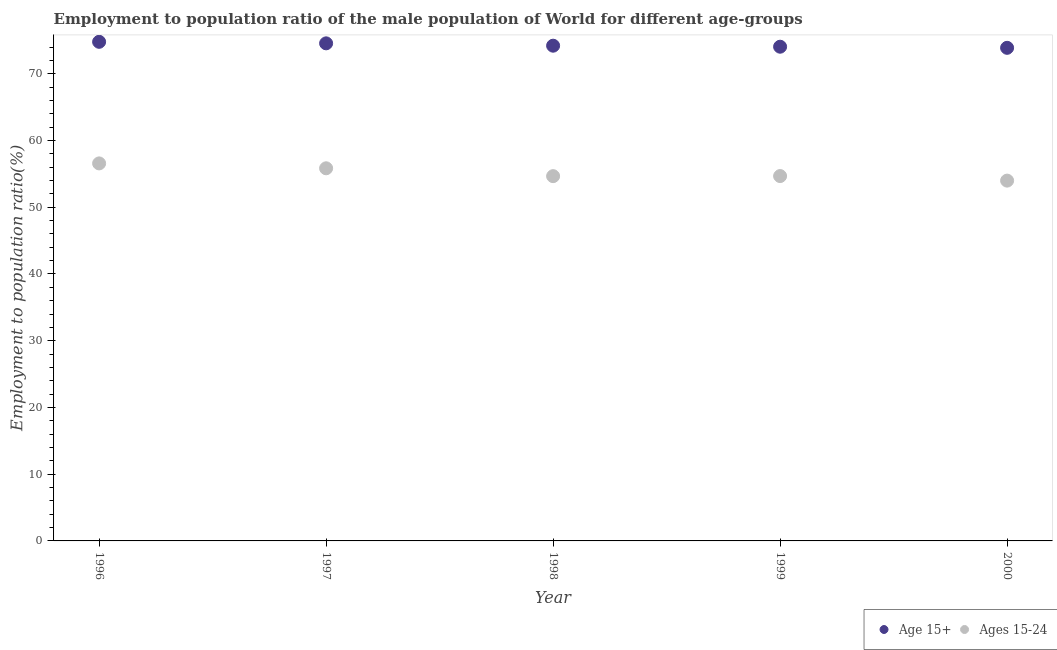How many different coloured dotlines are there?
Ensure brevity in your answer.  2. Is the number of dotlines equal to the number of legend labels?
Provide a succinct answer. Yes. What is the employment to population ratio(age 15+) in 1997?
Give a very brief answer. 74.57. Across all years, what is the maximum employment to population ratio(age 15-24)?
Provide a succinct answer. 56.57. Across all years, what is the minimum employment to population ratio(age 15-24)?
Keep it short and to the point. 53.99. In which year was the employment to population ratio(age 15+) maximum?
Your response must be concise. 1996. In which year was the employment to population ratio(age 15+) minimum?
Provide a succinct answer. 2000. What is the total employment to population ratio(age 15-24) in the graph?
Provide a succinct answer. 275.74. What is the difference between the employment to population ratio(age 15+) in 1997 and that in 1998?
Make the answer very short. 0.35. What is the difference between the employment to population ratio(age 15+) in 1997 and the employment to population ratio(age 15-24) in 1999?
Your response must be concise. 19.89. What is the average employment to population ratio(age 15+) per year?
Give a very brief answer. 74.3. In the year 1996, what is the difference between the employment to population ratio(age 15-24) and employment to population ratio(age 15+)?
Your response must be concise. -18.22. What is the ratio of the employment to population ratio(age 15-24) in 1996 to that in 1997?
Provide a short and direct response. 1.01. What is the difference between the highest and the second highest employment to population ratio(age 15-24)?
Your answer should be compact. 0.73. What is the difference between the highest and the lowest employment to population ratio(age 15-24)?
Your response must be concise. 2.58. In how many years, is the employment to population ratio(age 15-24) greater than the average employment to population ratio(age 15-24) taken over all years?
Your response must be concise. 2. Is the sum of the employment to population ratio(age 15+) in 1996 and 1998 greater than the maximum employment to population ratio(age 15-24) across all years?
Offer a very short reply. Yes. How many dotlines are there?
Make the answer very short. 2. What is the difference between two consecutive major ticks on the Y-axis?
Ensure brevity in your answer.  10. Does the graph contain any zero values?
Offer a very short reply. No. Does the graph contain grids?
Make the answer very short. No. What is the title of the graph?
Ensure brevity in your answer.  Employment to population ratio of the male population of World for different age-groups. Does "Study and work" appear as one of the legend labels in the graph?
Provide a short and direct response. No. What is the label or title of the Y-axis?
Your response must be concise. Employment to population ratio(%). What is the Employment to population ratio(%) of Age 15+ in 1996?
Provide a short and direct response. 74.79. What is the Employment to population ratio(%) of Ages 15-24 in 1996?
Ensure brevity in your answer.  56.57. What is the Employment to population ratio(%) of Age 15+ in 1997?
Your response must be concise. 74.57. What is the Employment to population ratio(%) of Ages 15-24 in 1997?
Your answer should be compact. 55.84. What is the Employment to population ratio(%) of Age 15+ in 1998?
Your answer should be very brief. 74.21. What is the Employment to population ratio(%) of Ages 15-24 in 1998?
Your answer should be compact. 54.66. What is the Employment to population ratio(%) in Age 15+ in 1999?
Ensure brevity in your answer.  74.06. What is the Employment to population ratio(%) in Ages 15-24 in 1999?
Your answer should be very brief. 54.68. What is the Employment to population ratio(%) in Age 15+ in 2000?
Make the answer very short. 73.89. What is the Employment to population ratio(%) of Ages 15-24 in 2000?
Offer a very short reply. 53.99. Across all years, what is the maximum Employment to population ratio(%) of Age 15+?
Your response must be concise. 74.79. Across all years, what is the maximum Employment to population ratio(%) of Ages 15-24?
Make the answer very short. 56.57. Across all years, what is the minimum Employment to population ratio(%) in Age 15+?
Your response must be concise. 73.89. Across all years, what is the minimum Employment to population ratio(%) of Ages 15-24?
Give a very brief answer. 53.99. What is the total Employment to population ratio(%) of Age 15+ in the graph?
Provide a short and direct response. 371.52. What is the total Employment to population ratio(%) in Ages 15-24 in the graph?
Your response must be concise. 275.74. What is the difference between the Employment to population ratio(%) in Age 15+ in 1996 and that in 1997?
Offer a very short reply. 0.23. What is the difference between the Employment to population ratio(%) in Ages 15-24 in 1996 and that in 1997?
Give a very brief answer. 0.73. What is the difference between the Employment to population ratio(%) of Age 15+ in 1996 and that in 1998?
Make the answer very short. 0.58. What is the difference between the Employment to population ratio(%) in Ages 15-24 in 1996 and that in 1998?
Provide a succinct answer. 1.91. What is the difference between the Employment to population ratio(%) of Age 15+ in 1996 and that in 1999?
Provide a short and direct response. 0.73. What is the difference between the Employment to population ratio(%) in Ages 15-24 in 1996 and that in 1999?
Your answer should be compact. 1.9. What is the difference between the Employment to population ratio(%) in Age 15+ in 1996 and that in 2000?
Make the answer very short. 0.9. What is the difference between the Employment to population ratio(%) of Ages 15-24 in 1996 and that in 2000?
Give a very brief answer. 2.58. What is the difference between the Employment to population ratio(%) in Age 15+ in 1997 and that in 1998?
Offer a terse response. 0.35. What is the difference between the Employment to population ratio(%) in Ages 15-24 in 1997 and that in 1998?
Your response must be concise. 1.18. What is the difference between the Employment to population ratio(%) in Age 15+ in 1997 and that in 1999?
Your response must be concise. 0.51. What is the difference between the Employment to population ratio(%) of Ages 15-24 in 1997 and that in 1999?
Your answer should be compact. 1.16. What is the difference between the Employment to population ratio(%) in Age 15+ in 1997 and that in 2000?
Your response must be concise. 0.67. What is the difference between the Employment to population ratio(%) of Ages 15-24 in 1997 and that in 2000?
Keep it short and to the point. 1.85. What is the difference between the Employment to population ratio(%) of Age 15+ in 1998 and that in 1999?
Make the answer very short. 0.15. What is the difference between the Employment to population ratio(%) in Ages 15-24 in 1998 and that in 1999?
Your answer should be compact. -0.01. What is the difference between the Employment to population ratio(%) of Age 15+ in 1998 and that in 2000?
Offer a terse response. 0.32. What is the difference between the Employment to population ratio(%) of Ages 15-24 in 1998 and that in 2000?
Your answer should be compact. 0.67. What is the difference between the Employment to population ratio(%) in Age 15+ in 1999 and that in 2000?
Offer a very short reply. 0.17. What is the difference between the Employment to population ratio(%) in Ages 15-24 in 1999 and that in 2000?
Provide a short and direct response. 0.68. What is the difference between the Employment to population ratio(%) in Age 15+ in 1996 and the Employment to population ratio(%) in Ages 15-24 in 1997?
Your answer should be compact. 18.95. What is the difference between the Employment to population ratio(%) in Age 15+ in 1996 and the Employment to population ratio(%) in Ages 15-24 in 1998?
Keep it short and to the point. 20.13. What is the difference between the Employment to population ratio(%) in Age 15+ in 1996 and the Employment to population ratio(%) in Ages 15-24 in 1999?
Keep it short and to the point. 20.12. What is the difference between the Employment to population ratio(%) of Age 15+ in 1996 and the Employment to population ratio(%) of Ages 15-24 in 2000?
Your answer should be very brief. 20.8. What is the difference between the Employment to population ratio(%) in Age 15+ in 1997 and the Employment to population ratio(%) in Ages 15-24 in 1998?
Offer a terse response. 19.9. What is the difference between the Employment to population ratio(%) in Age 15+ in 1997 and the Employment to population ratio(%) in Ages 15-24 in 1999?
Offer a terse response. 19.89. What is the difference between the Employment to population ratio(%) of Age 15+ in 1997 and the Employment to population ratio(%) of Ages 15-24 in 2000?
Give a very brief answer. 20.57. What is the difference between the Employment to population ratio(%) of Age 15+ in 1998 and the Employment to population ratio(%) of Ages 15-24 in 1999?
Give a very brief answer. 19.54. What is the difference between the Employment to population ratio(%) in Age 15+ in 1998 and the Employment to population ratio(%) in Ages 15-24 in 2000?
Make the answer very short. 20.22. What is the difference between the Employment to population ratio(%) in Age 15+ in 1999 and the Employment to population ratio(%) in Ages 15-24 in 2000?
Ensure brevity in your answer.  20.07. What is the average Employment to population ratio(%) in Age 15+ per year?
Offer a very short reply. 74.3. What is the average Employment to population ratio(%) of Ages 15-24 per year?
Keep it short and to the point. 55.15. In the year 1996, what is the difference between the Employment to population ratio(%) in Age 15+ and Employment to population ratio(%) in Ages 15-24?
Offer a very short reply. 18.22. In the year 1997, what is the difference between the Employment to population ratio(%) in Age 15+ and Employment to population ratio(%) in Ages 15-24?
Keep it short and to the point. 18.72. In the year 1998, what is the difference between the Employment to population ratio(%) of Age 15+ and Employment to population ratio(%) of Ages 15-24?
Make the answer very short. 19.55. In the year 1999, what is the difference between the Employment to population ratio(%) of Age 15+ and Employment to population ratio(%) of Ages 15-24?
Make the answer very short. 19.38. In the year 2000, what is the difference between the Employment to population ratio(%) of Age 15+ and Employment to population ratio(%) of Ages 15-24?
Your response must be concise. 19.9. What is the ratio of the Employment to population ratio(%) of Ages 15-24 in 1996 to that in 1997?
Provide a short and direct response. 1.01. What is the ratio of the Employment to population ratio(%) in Age 15+ in 1996 to that in 1998?
Provide a succinct answer. 1.01. What is the ratio of the Employment to population ratio(%) of Ages 15-24 in 1996 to that in 1998?
Your answer should be compact. 1.03. What is the ratio of the Employment to population ratio(%) of Age 15+ in 1996 to that in 1999?
Make the answer very short. 1.01. What is the ratio of the Employment to population ratio(%) of Ages 15-24 in 1996 to that in 1999?
Your answer should be compact. 1.03. What is the ratio of the Employment to population ratio(%) of Age 15+ in 1996 to that in 2000?
Your answer should be compact. 1.01. What is the ratio of the Employment to population ratio(%) in Ages 15-24 in 1996 to that in 2000?
Offer a terse response. 1.05. What is the ratio of the Employment to population ratio(%) in Ages 15-24 in 1997 to that in 1998?
Offer a very short reply. 1.02. What is the ratio of the Employment to population ratio(%) in Age 15+ in 1997 to that in 1999?
Offer a terse response. 1.01. What is the ratio of the Employment to population ratio(%) of Ages 15-24 in 1997 to that in 1999?
Your response must be concise. 1.02. What is the ratio of the Employment to population ratio(%) of Age 15+ in 1997 to that in 2000?
Ensure brevity in your answer.  1.01. What is the ratio of the Employment to population ratio(%) of Ages 15-24 in 1997 to that in 2000?
Provide a succinct answer. 1.03. What is the ratio of the Employment to population ratio(%) of Age 15+ in 1998 to that in 1999?
Give a very brief answer. 1. What is the ratio of the Employment to population ratio(%) in Ages 15-24 in 1998 to that in 2000?
Keep it short and to the point. 1.01. What is the ratio of the Employment to population ratio(%) in Ages 15-24 in 1999 to that in 2000?
Offer a terse response. 1.01. What is the difference between the highest and the second highest Employment to population ratio(%) of Age 15+?
Provide a short and direct response. 0.23. What is the difference between the highest and the second highest Employment to population ratio(%) in Ages 15-24?
Provide a succinct answer. 0.73. What is the difference between the highest and the lowest Employment to population ratio(%) in Age 15+?
Make the answer very short. 0.9. What is the difference between the highest and the lowest Employment to population ratio(%) in Ages 15-24?
Ensure brevity in your answer.  2.58. 